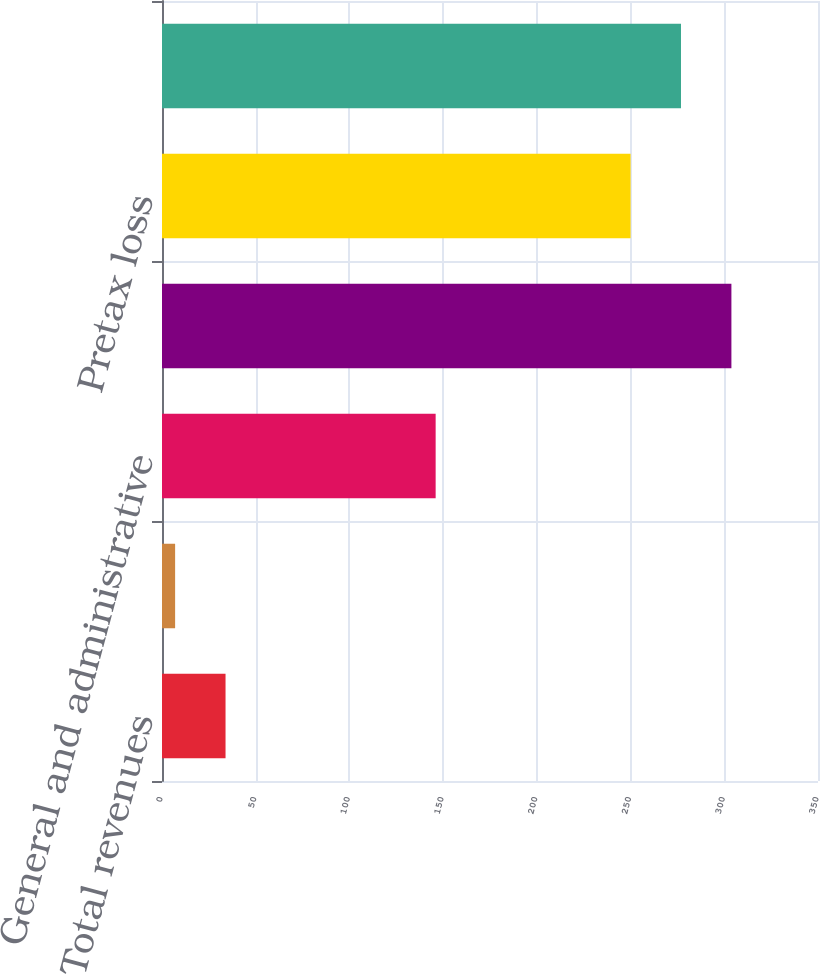Convert chart to OTSL. <chart><loc_0><loc_0><loc_500><loc_500><bar_chart><fcel>Total revenues<fcel>Banking and deposit interest<fcel>General and administrative<fcel>Total expenses<fcel>Pretax loss<fcel>Pretax loss attributable to<nl><fcel>33.9<fcel>7<fcel>146<fcel>303.8<fcel>250<fcel>276.9<nl></chart> 